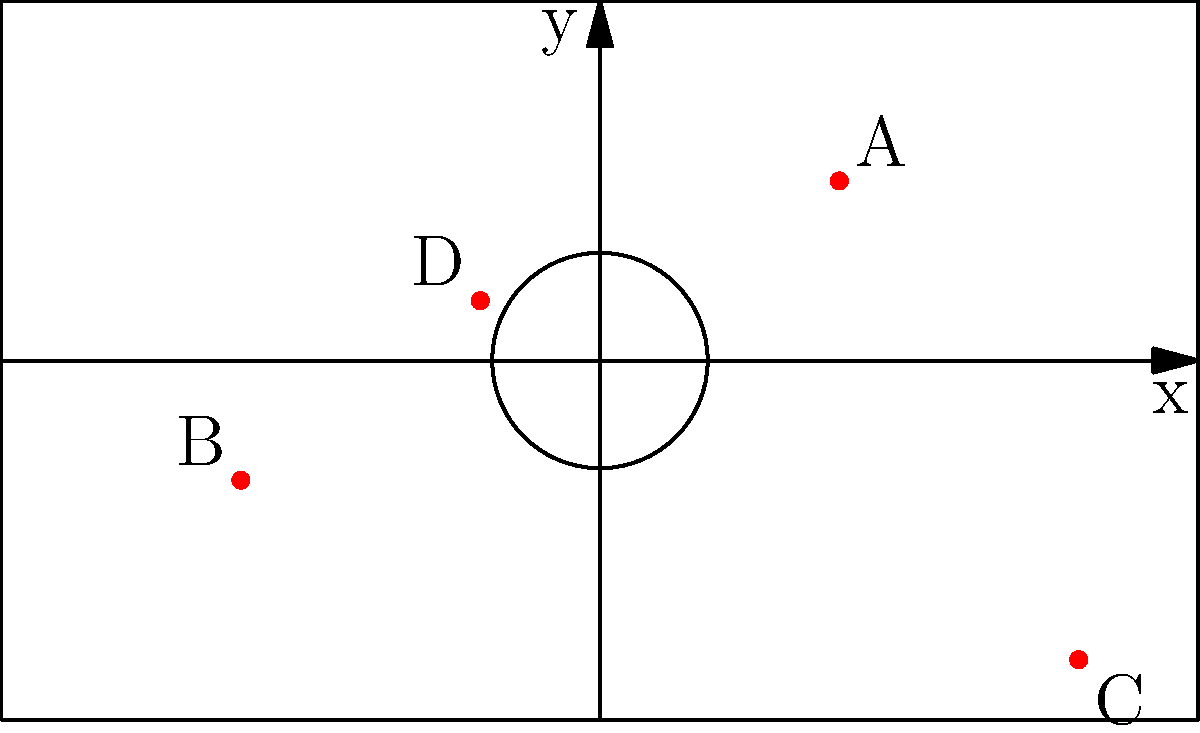On the football pitch shown above, four Argentine-born players who chose to represent other countries are plotted as red dots (A, B, C, and D). Which player is positioned closest to the center of the pitch? Assume the center of the pitch is at coordinates (0,0). To find the player closest to the center of the pitch (0,0), we need to calculate the distance of each player from the origin using the distance formula:

Distance = $\sqrt{(x_2-x_1)^2 + (y_2-y_1)^2}$

Where $(x_1,y_1)$ is (0,0) and $(x_2,y_2)$ is the player's position.

Let's calculate for each player:

1. Player A (20,15):
   Distance = $\sqrt{(20-0)^2 + (15-0)^2} = \sqrt{400 + 225} = \sqrt{625} = 25$

2. Player B (-30,-10):
   Distance = $\sqrt{(-30-0)^2 + (-10-0)^2} = \sqrt{900 + 100} = \sqrt{1000} \approx 31.62$

3. Player C (40,-25):
   Distance = $\sqrt{(40-0)^2 + (-25-0)^2} = \sqrt{1600 + 625} = \sqrt{2225} \approx 47.17$

4. Player D (-10,5):
   Distance = $\sqrt{(-10-0)^2 + (5-0)^2} = \sqrt{100 + 25} = \sqrt{125} \approx 11.18$

Player D has the shortest distance to the center, approximately 11.18 units.
Answer: Player D 